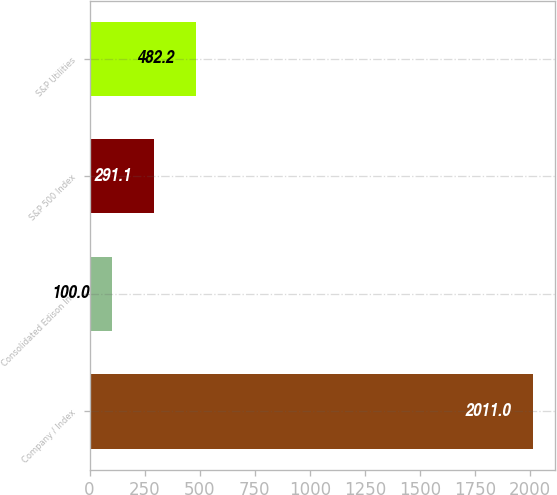Convert chart. <chart><loc_0><loc_0><loc_500><loc_500><bar_chart><fcel>Company / Index<fcel>Consolidated Edison Inc<fcel>S&P 500 Index<fcel>S&P Utilities<nl><fcel>2011<fcel>100<fcel>291.1<fcel>482.2<nl></chart> 